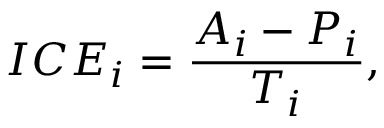<formula> <loc_0><loc_0><loc_500><loc_500>I C E _ { i } = \frac { A _ { i } - P _ { i } } { T _ { i } } ,</formula> 